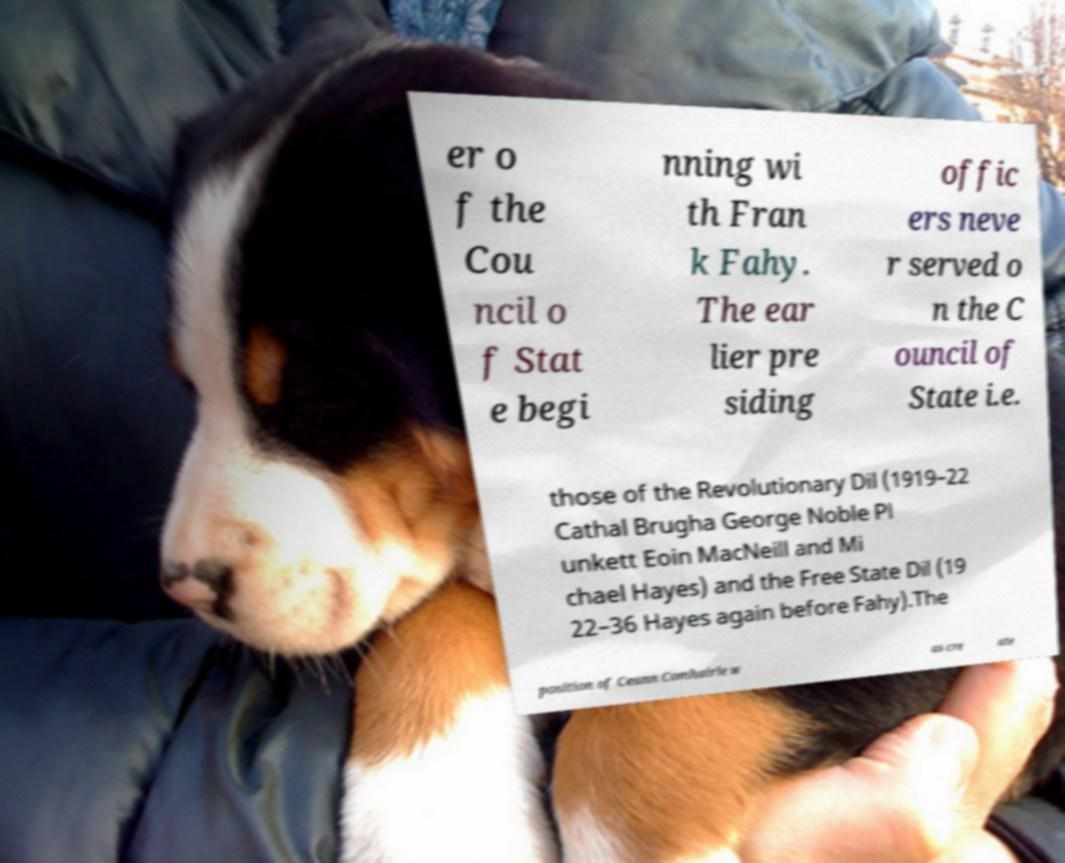Could you assist in decoding the text presented in this image and type it out clearly? er o f the Cou ncil o f Stat e begi nning wi th Fran k Fahy. The ear lier pre siding offic ers neve r served o n the C ouncil of State i.e. those of the Revolutionary Dil (1919–22 Cathal Brugha George Noble Pl unkett Eoin MacNeill and Mi chael Hayes) and the Free State Dil (19 22–36 Hayes again before Fahy).The position of Ceann Comhairle w as cre ate 